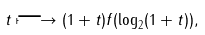<formula> <loc_0><loc_0><loc_500><loc_500>t \longmapsto ( 1 + t ) f ( \log _ { 2 } ( 1 + t ) ) ,</formula> 